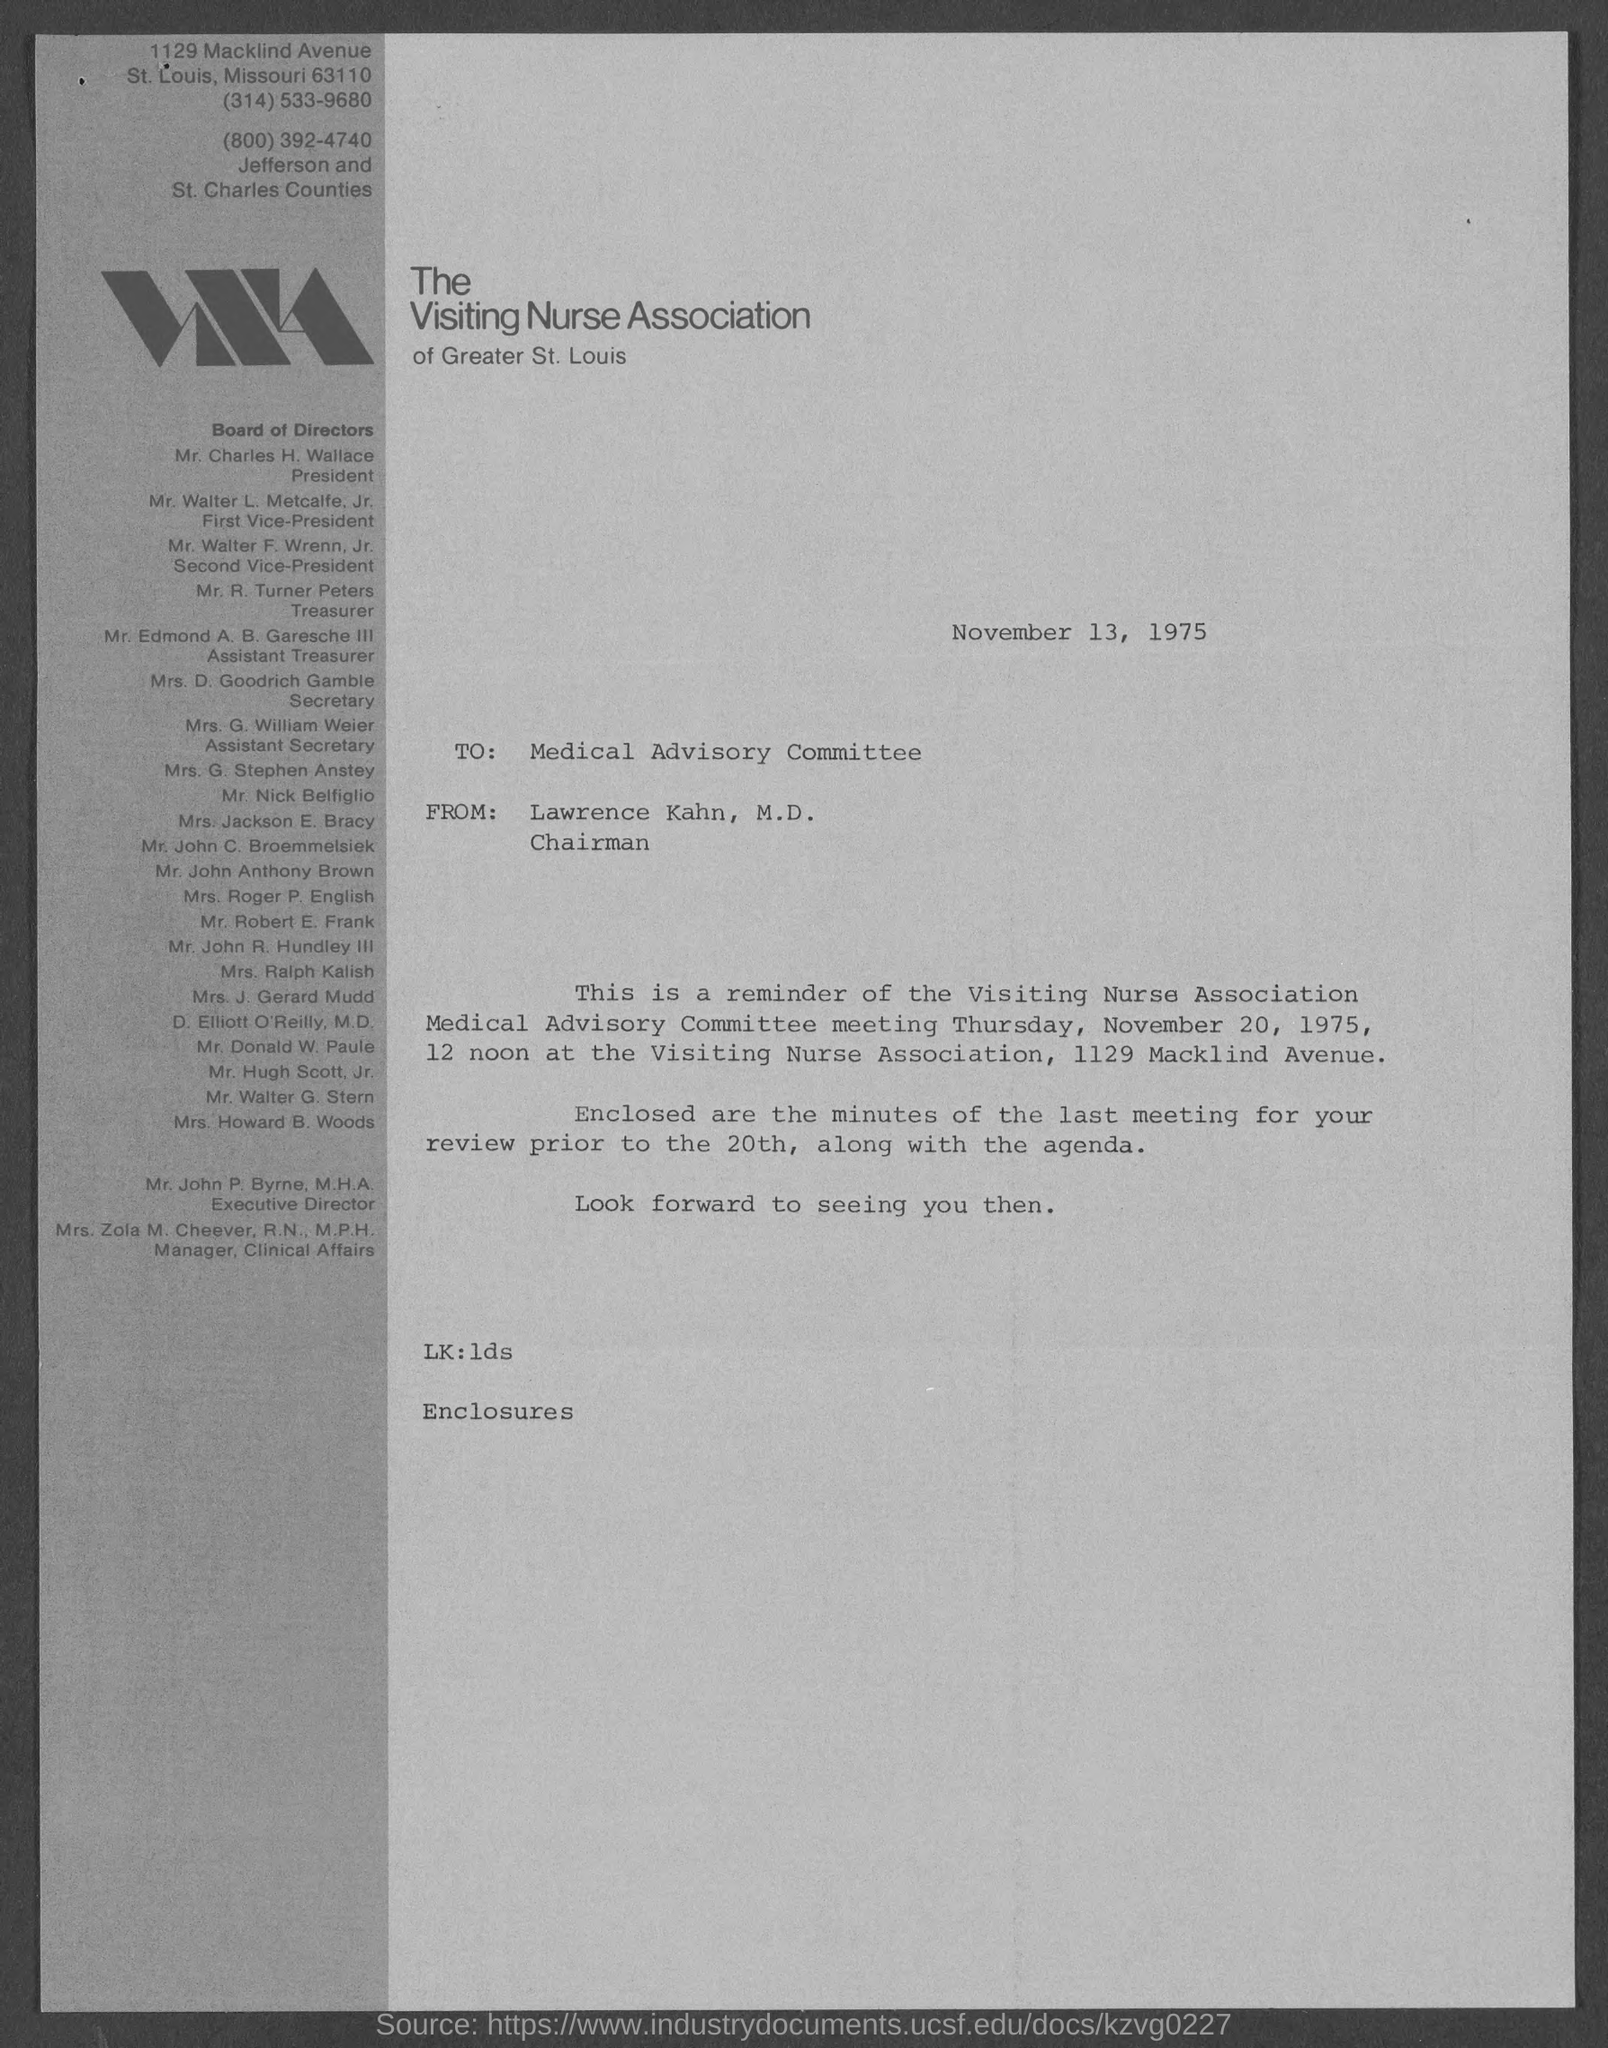Which association is mentioned?
Make the answer very short. The visiting nurse association. When is the document dated?
Offer a terse response. November 13, 1975. To whom is the letter addressed?
Offer a very short reply. Medical Advisory Committee. From whom is the letter?
Your response must be concise. Lawrence kahn, m.d. Who is the president?
Make the answer very short. Mr. Charles H. Wallace. 